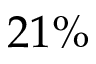<formula> <loc_0><loc_0><loc_500><loc_500>2 1 \%</formula> 